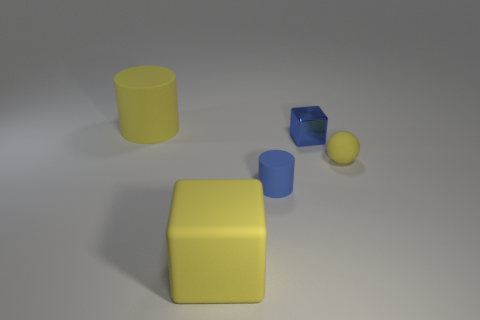What size is the blue object in front of the small metallic cube?
Your response must be concise. Small. What is the large yellow block made of?
Your answer should be compact. Rubber. The big yellow rubber object that is in front of the cube behind the big yellow matte block is what shape?
Offer a terse response. Cube. How many other things are there of the same shape as the small metal object?
Make the answer very short. 1. There is a small blue rubber thing; are there any cylinders on the left side of it?
Your answer should be very brief. Yes. What color is the tiny rubber sphere?
Keep it short and to the point. Yellow. There is a small cylinder; does it have the same color as the large rubber block that is in front of the tiny cylinder?
Keep it short and to the point. No. Is there a gray object that has the same size as the matte cube?
Your response must be concise. No. What size is the cylinder that is the same color as the tiny rubber ball?
Offer a very short reply. Large. What is the material of the small blue thing that is on the right side of the blue cylinder?
Offer a terse response. Metal. 